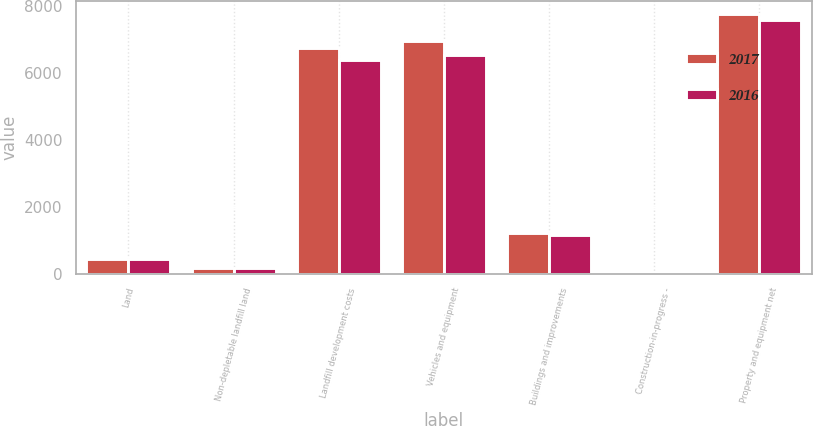<chart> <loc_0><loc_0><loc_500><loc_500><stacked_bar_chart><ecel><fcel>Land<fcel>Non-depletable landfill land<fcel>Landfill development costs<fcel>Vehicles and equipment<fcel>Buildings and improvements<fcel>Construction-in-progress -<fcel>Property and equipment net<nl><fcel>2017<fcel>433.2<fcel>166.9<fcel>6757.3<fcel>6954.3<fcel>1221.5<fcel>55.7<fcel>7777.4<nl><fcel>2016<fcel>430.2<fcel>166.8<fcel>6386.7<fcel>6551.8<fcel>1160.1<fcel>35.7<fcel>7588.6<nl></chart> 